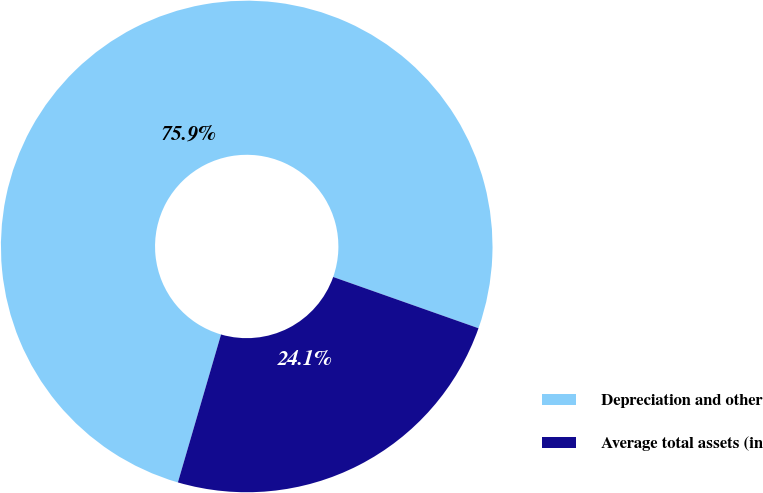<chart> <loc_0><loc_0><loc_500><loc_500><pie_chart><fcel>Depreciation and other<fcel>Average total assets (in<nl><fcel>75.88%<fcel>24.12%<nl></chart> 